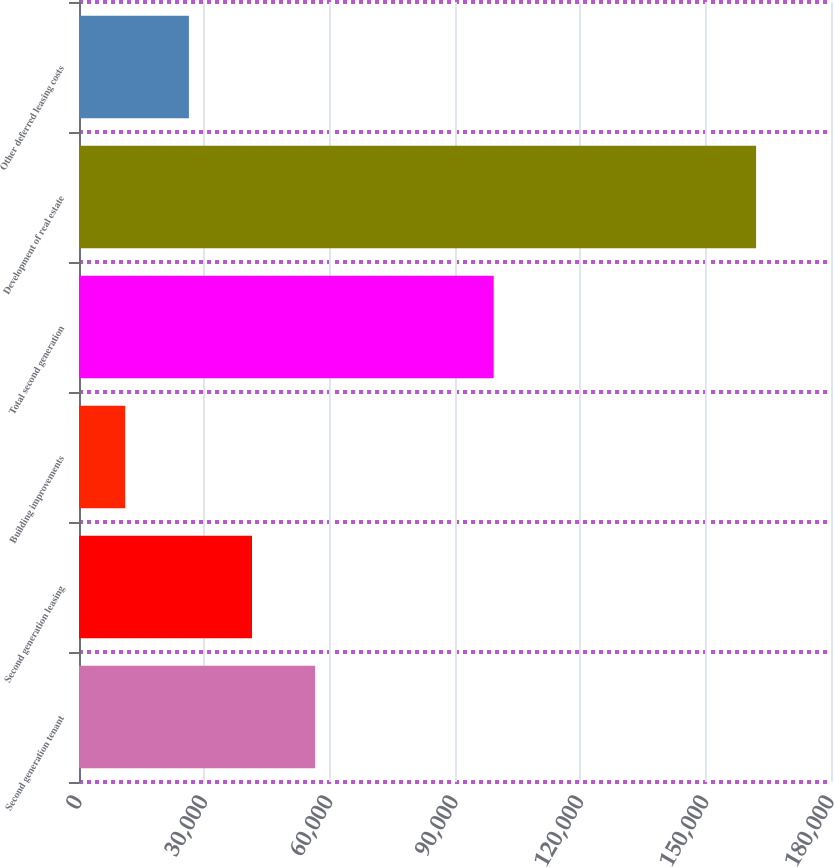<chart> <loc_0><loc_0><loc_500><loc_500><bar_chart><fcel>Second generation tenant<fcel>Second generation leasing<fcel>Building improvements<fcel>Total second generation<fcel>Development of real estate<fcel>Other deferred leasing costs<nl><fcel>56514<fcel>41412.5<fcel>11055<fcel>99264<fcel>162070<fcel>26311<nl></chart> 